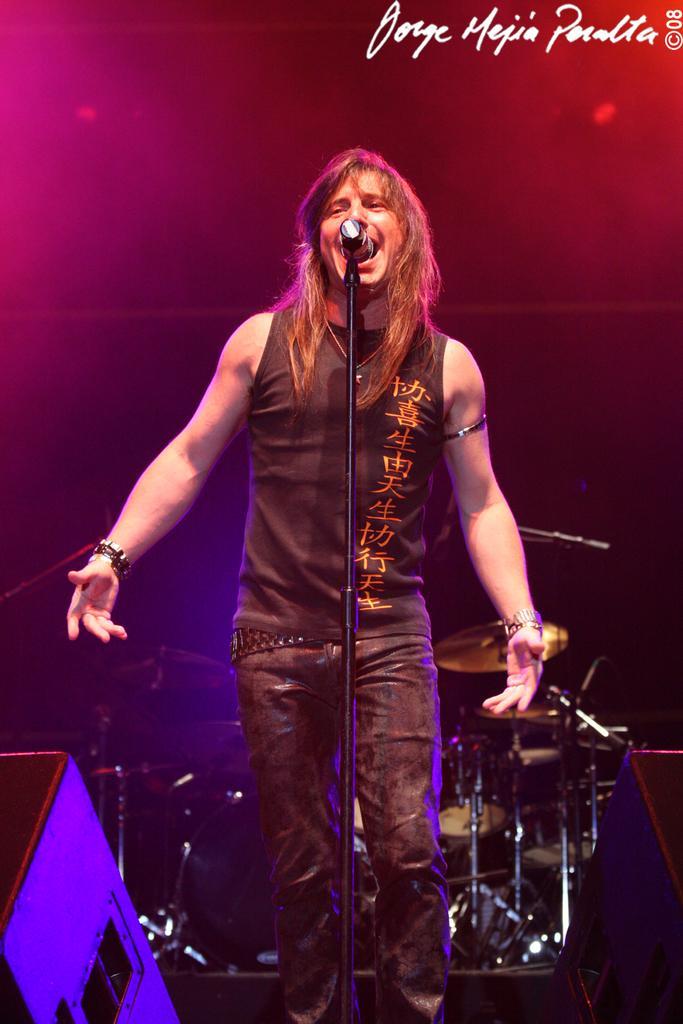In one or two sentences, can you explain what this image depicts? In this image, we can see a person standing and singing into the microphone, in the background we can see some musical instruments. 